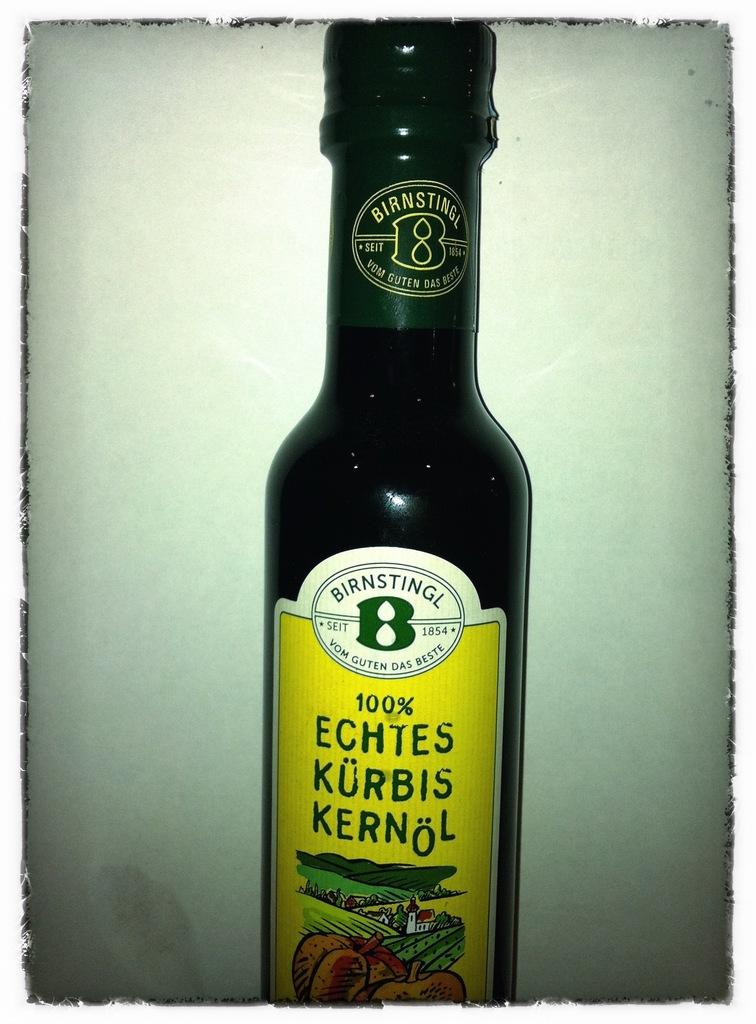<image>
Create a compact narrative representing the image presented. The bottle of Echtes Kurbis Kernol is a type of oil that is bottled. 